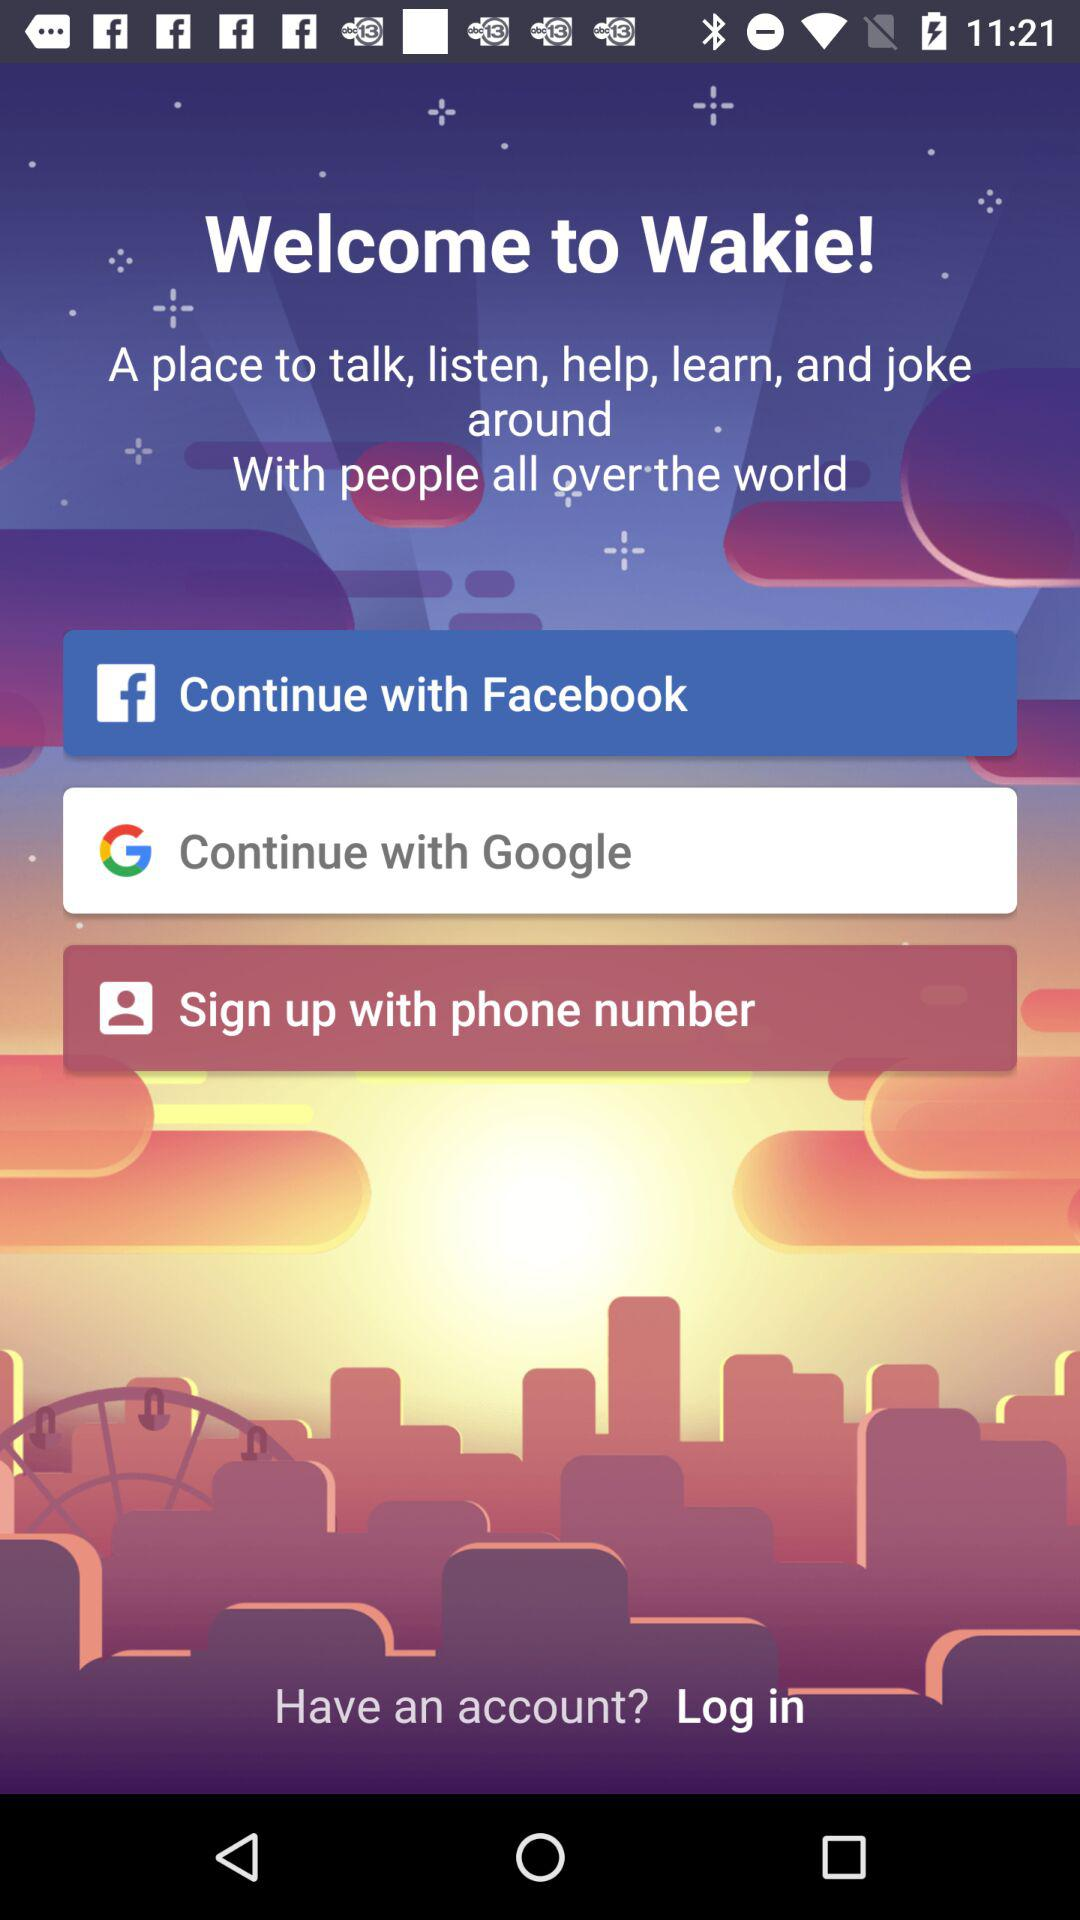How many sign up options are there?
Answer the question using a single word or phrase. 3 